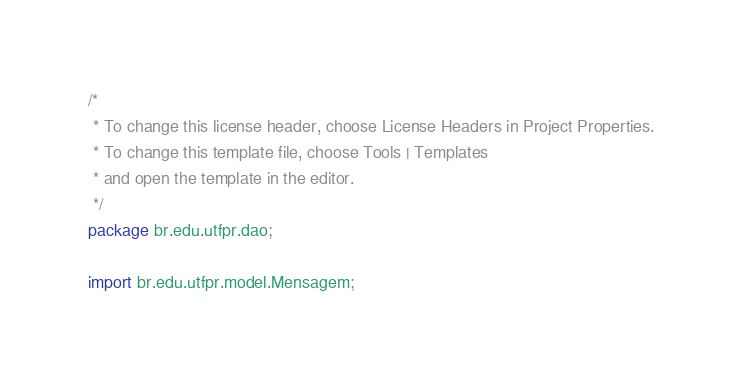<code> <loc_0><loc_0><loc_500><loc_500><_Java_>/*
 * To change this license header, choose License Headers in Project Properties.
 * To change this template file, choose Tools | Templates
 * and open the template in the editor.
 */
package br.edu.utfpr.dao;

import br.edu.utfpr.model.Mensagem;</code> 